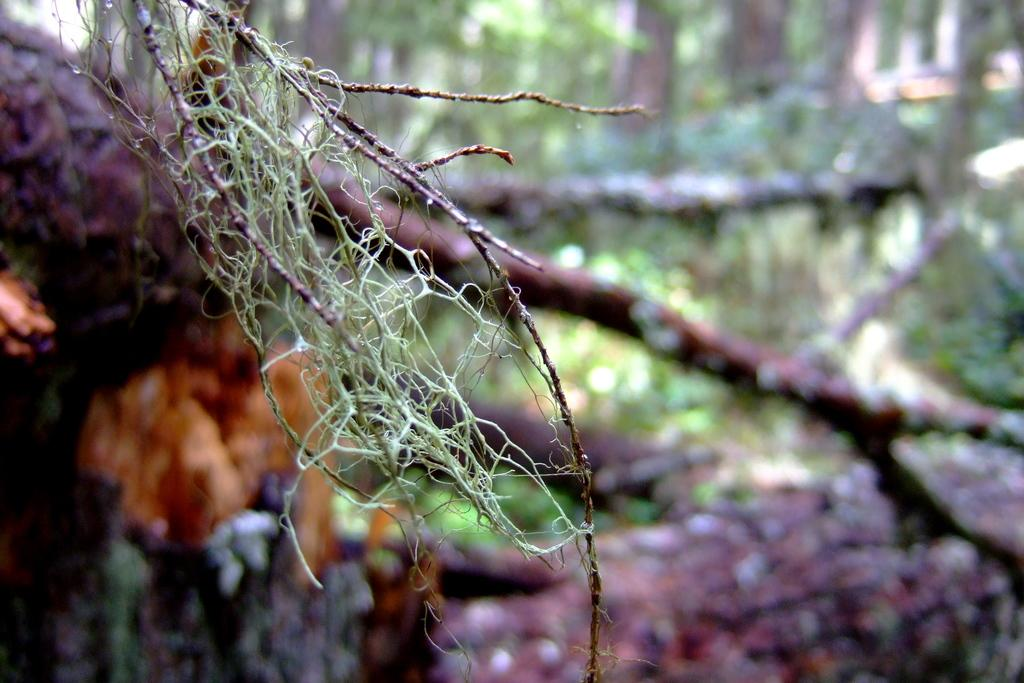What is the main subject of the image? The main subject of the image is a dried branch of a tree. Can you describe the background of the image? The background of the image is partially blurred. What type of rake is being used to clean the tank in the image? There is no rake or tank present in the image; it features a dried branch of a tree and a partially blurred background. 